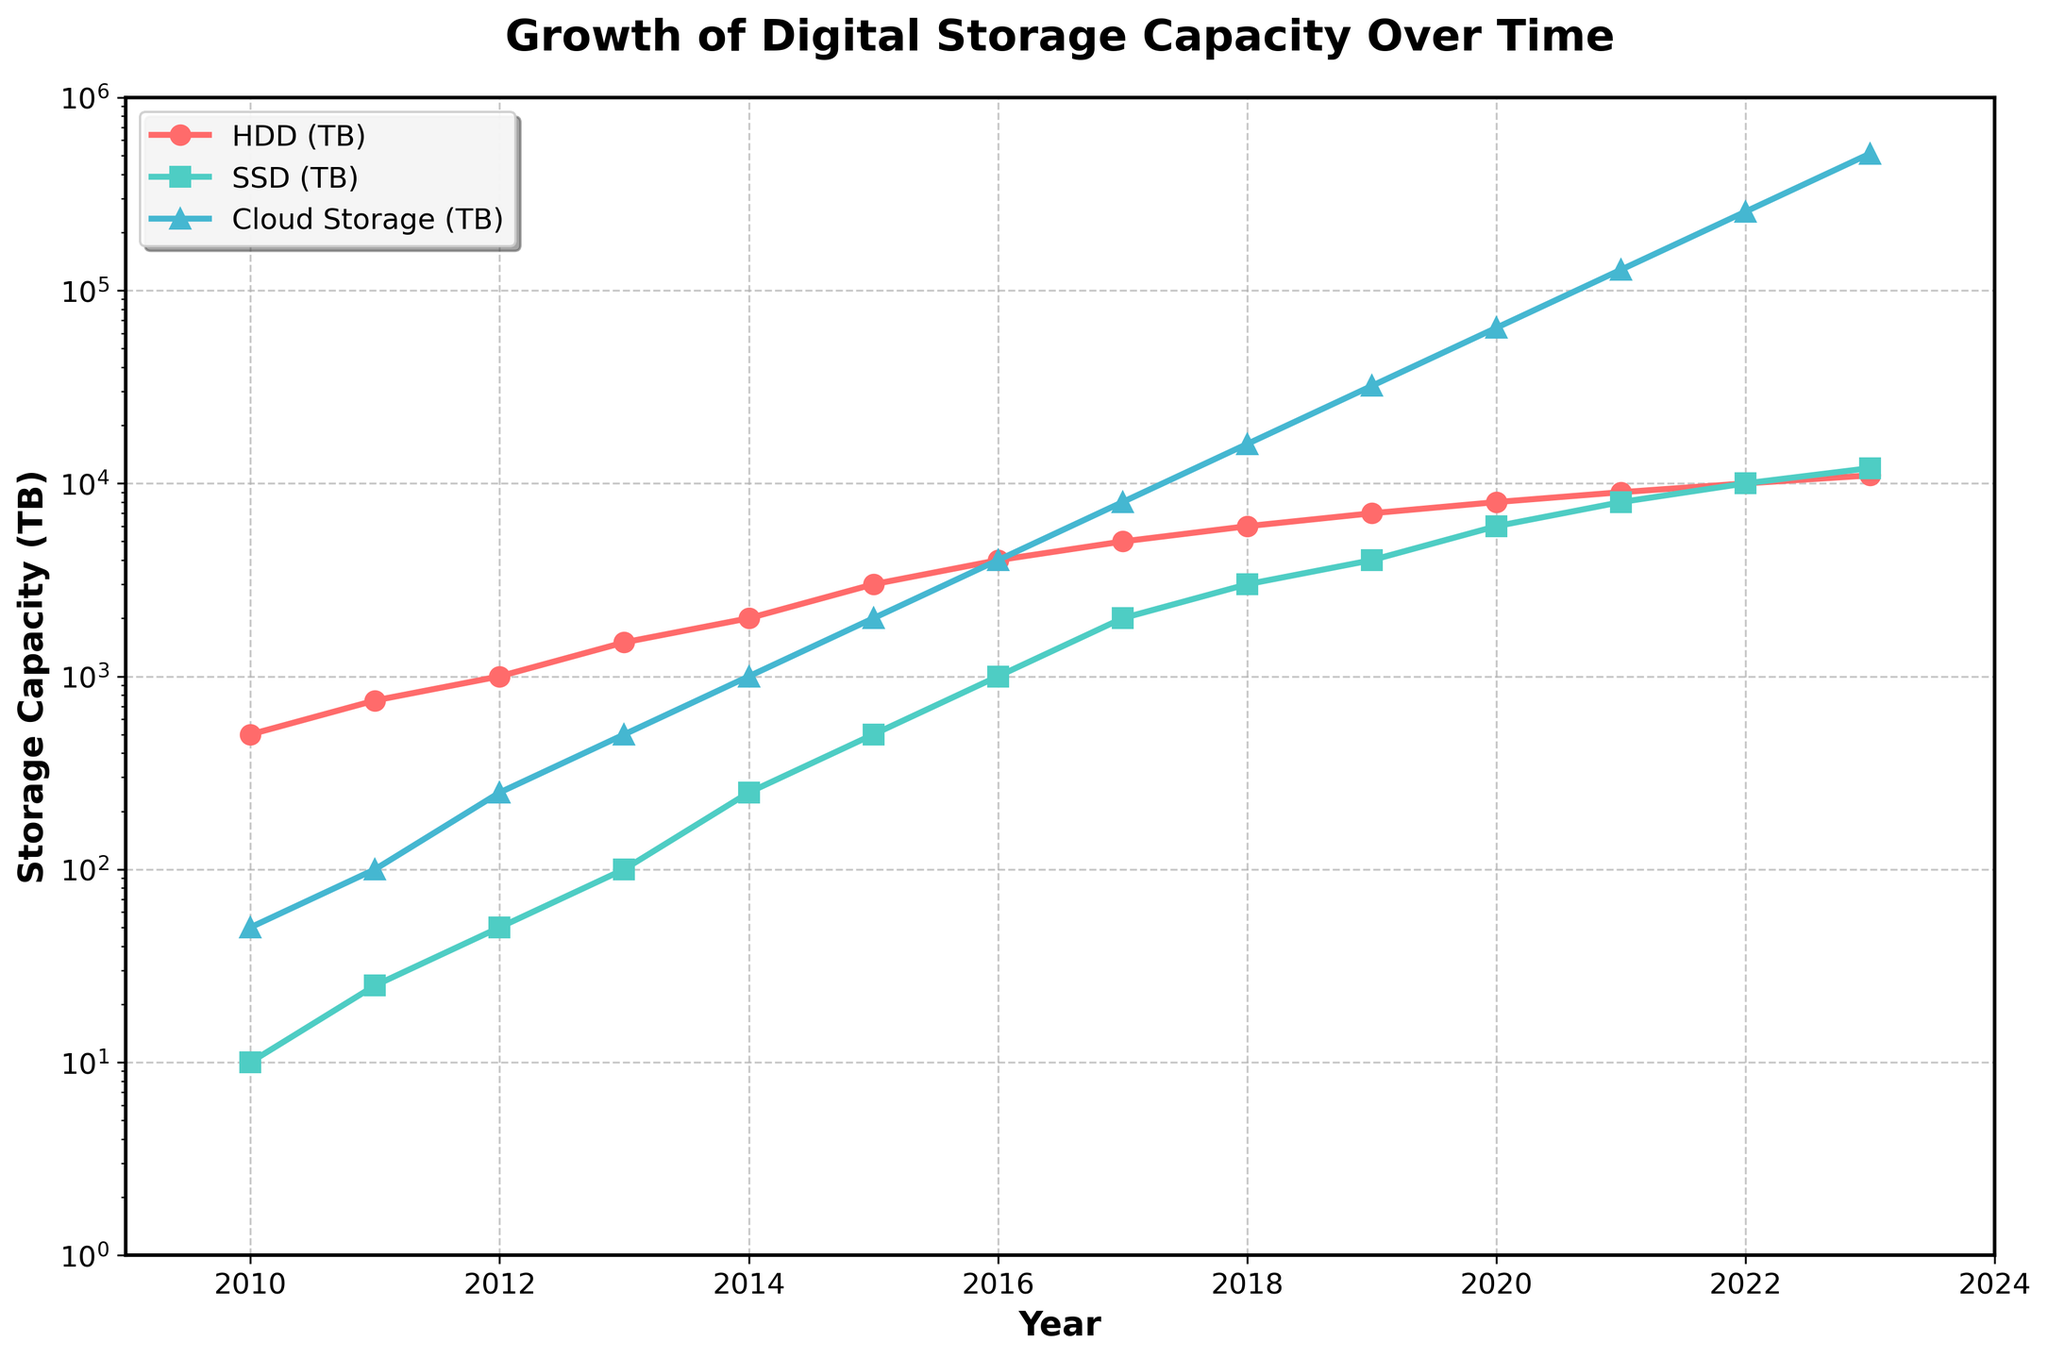What is the overall trend in the growth of digital storage capacity over time? The line chart shows an overall upward trend in the storage capacities for HDD, SSD, and Cloud storage, indicating a significant increase in digital storage capacity over time. The total storage capacity also shows exponential growth from 2010 to 2023.
Answer: Upward trend Which storage type has shown the most significant growth from 2010 to 2023? By comparing the slopes of the lines for HDD, SSD, and Cloud Storage, Cloud Storage shows the most significant growth, especially apparent from 2015 onwards, where it rapidly increases to surpass the other types by a large margin.
Answer: Cloud Storage In what year did the total storage capacity first exceed 10,000 TB? By checking the Total (TB) line on the plot and the corresponding year labels, the total storage capacity first exceeded 10,000 TB in 2015.
Answer: 2015 How many times greater is the Cloud Storage capacity in 2023 compared to 2010? In 2010, the Cloud Storage capacity is 50 TB, and in 2023 it is 512,000 TB. Dividing 512,000 by 50 gives 10,240.
Answer: 10,240 times How do the growth rates of SSD and Cloud Storage compare between 2010 and 2020? By comparing the slopes of the SSD and Cloud Storage lines, Cloud Storage shows an exponentially steeper growth rate compared to SSD, especially evident after 2015.
Answer: Cloud Storage's growth rate is much higher Between which consecutive years did HDD storage capacity grow the most? By comparing the year-to-year differences in the HDD capacity line, the largest increase is between 2014 (2,000 TB) and 2015 (3,000 TB), equating to an increase of 1,000 TB.
Answer: 2014-2015 What is the percentage contribution of Cloud Storage to the total storage capacity in 2023? In 2023, Cloud Storage capacity is 512,000 TB, and the total capacity is 535,000 TB. The percentage contribution is (512,000 / 535,000) * 100, which equals approximately 95.69%.
Answer: 95.69% Which year saw equal storage capacities for both HDD and SSD storage types? By checking the plot, the year when both HDD and SSD capacities are equal is 2022, with both having 10,000 TB.
Answer: 2022 What is the average yearly increase in Cloud Storage capacity between 2010 and 2015? In 2010, Cloud Storage capacity is 50 TB, and in 2015 it is 2,000 TB. The increase is 2,000 - 50 = 1,950 TB over 5 years. The average yearly increase is 1,950 / 5 = 390 TB.
Answer: 390 TB per year Is there any year where HDD capacity decreases compared to the previous year? By checking the line chart for HDD capacity, there is no year from 2010 to 2023 where HDD capacity decreases compared to the previous year.
Answer: No 